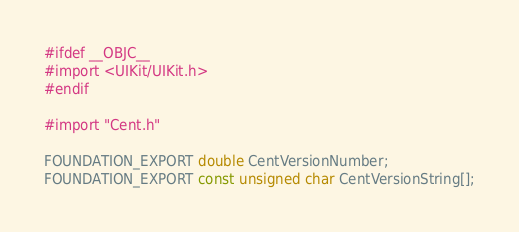<code> <loc_0><loc_0><loc_500><loc_500><_C_>#ifdef __OBJC__
#import <UIKit/UIKit.h>
#endif

#import "Cent.h"

FOUNDATION_EXPORT double CentVersionNumber;
FOUNDATION_EXPORT const unsigned char CentVersionString[];

</code> 